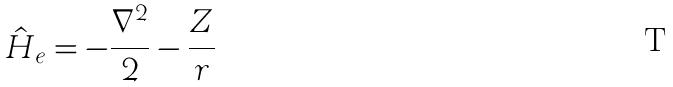Convert formula to latex. <formula><loc_0><loc_0><loc_500><loc_500>\hat { H } _ { e } = - \frac { \nabla ^ { 2 } } { 2 } - \frac { Z } { r }</formula> 